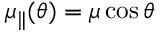Convert formula to latex. <formula><loc_0><loc_0><loc_500><loc_500>\mu _ { \| } ( \theta ) = \mu \cos { \theta }</formula> 